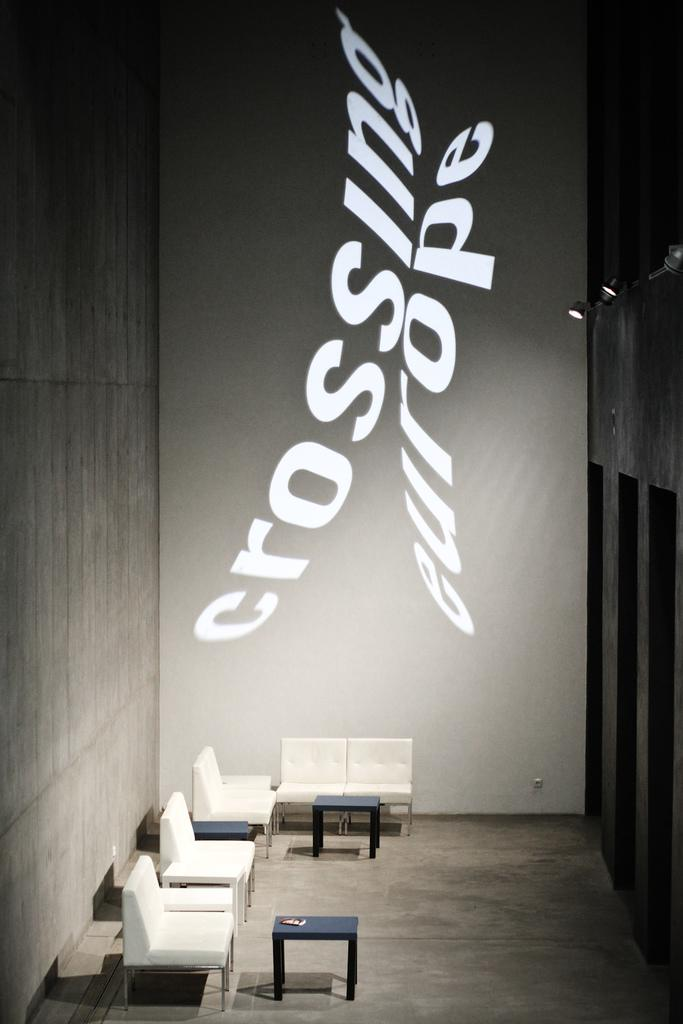What type of setting is depicted in the image? The image is an indoor scene. What type of furniture is present in the image? There are chairs and tables in the image. What can be seen illuminating the scene? There are lights in the image. What message or theme is conveyed by the board in the image? The board in the image has the text "Crossing Europe," which suggests a theme related to travel or exploration. What type of screw is being used to hold the band together in the image? There is no band or screw present in the image; it features an indoor scene with chairs, tables, lights, and a board with the text "Crossing Europe." 